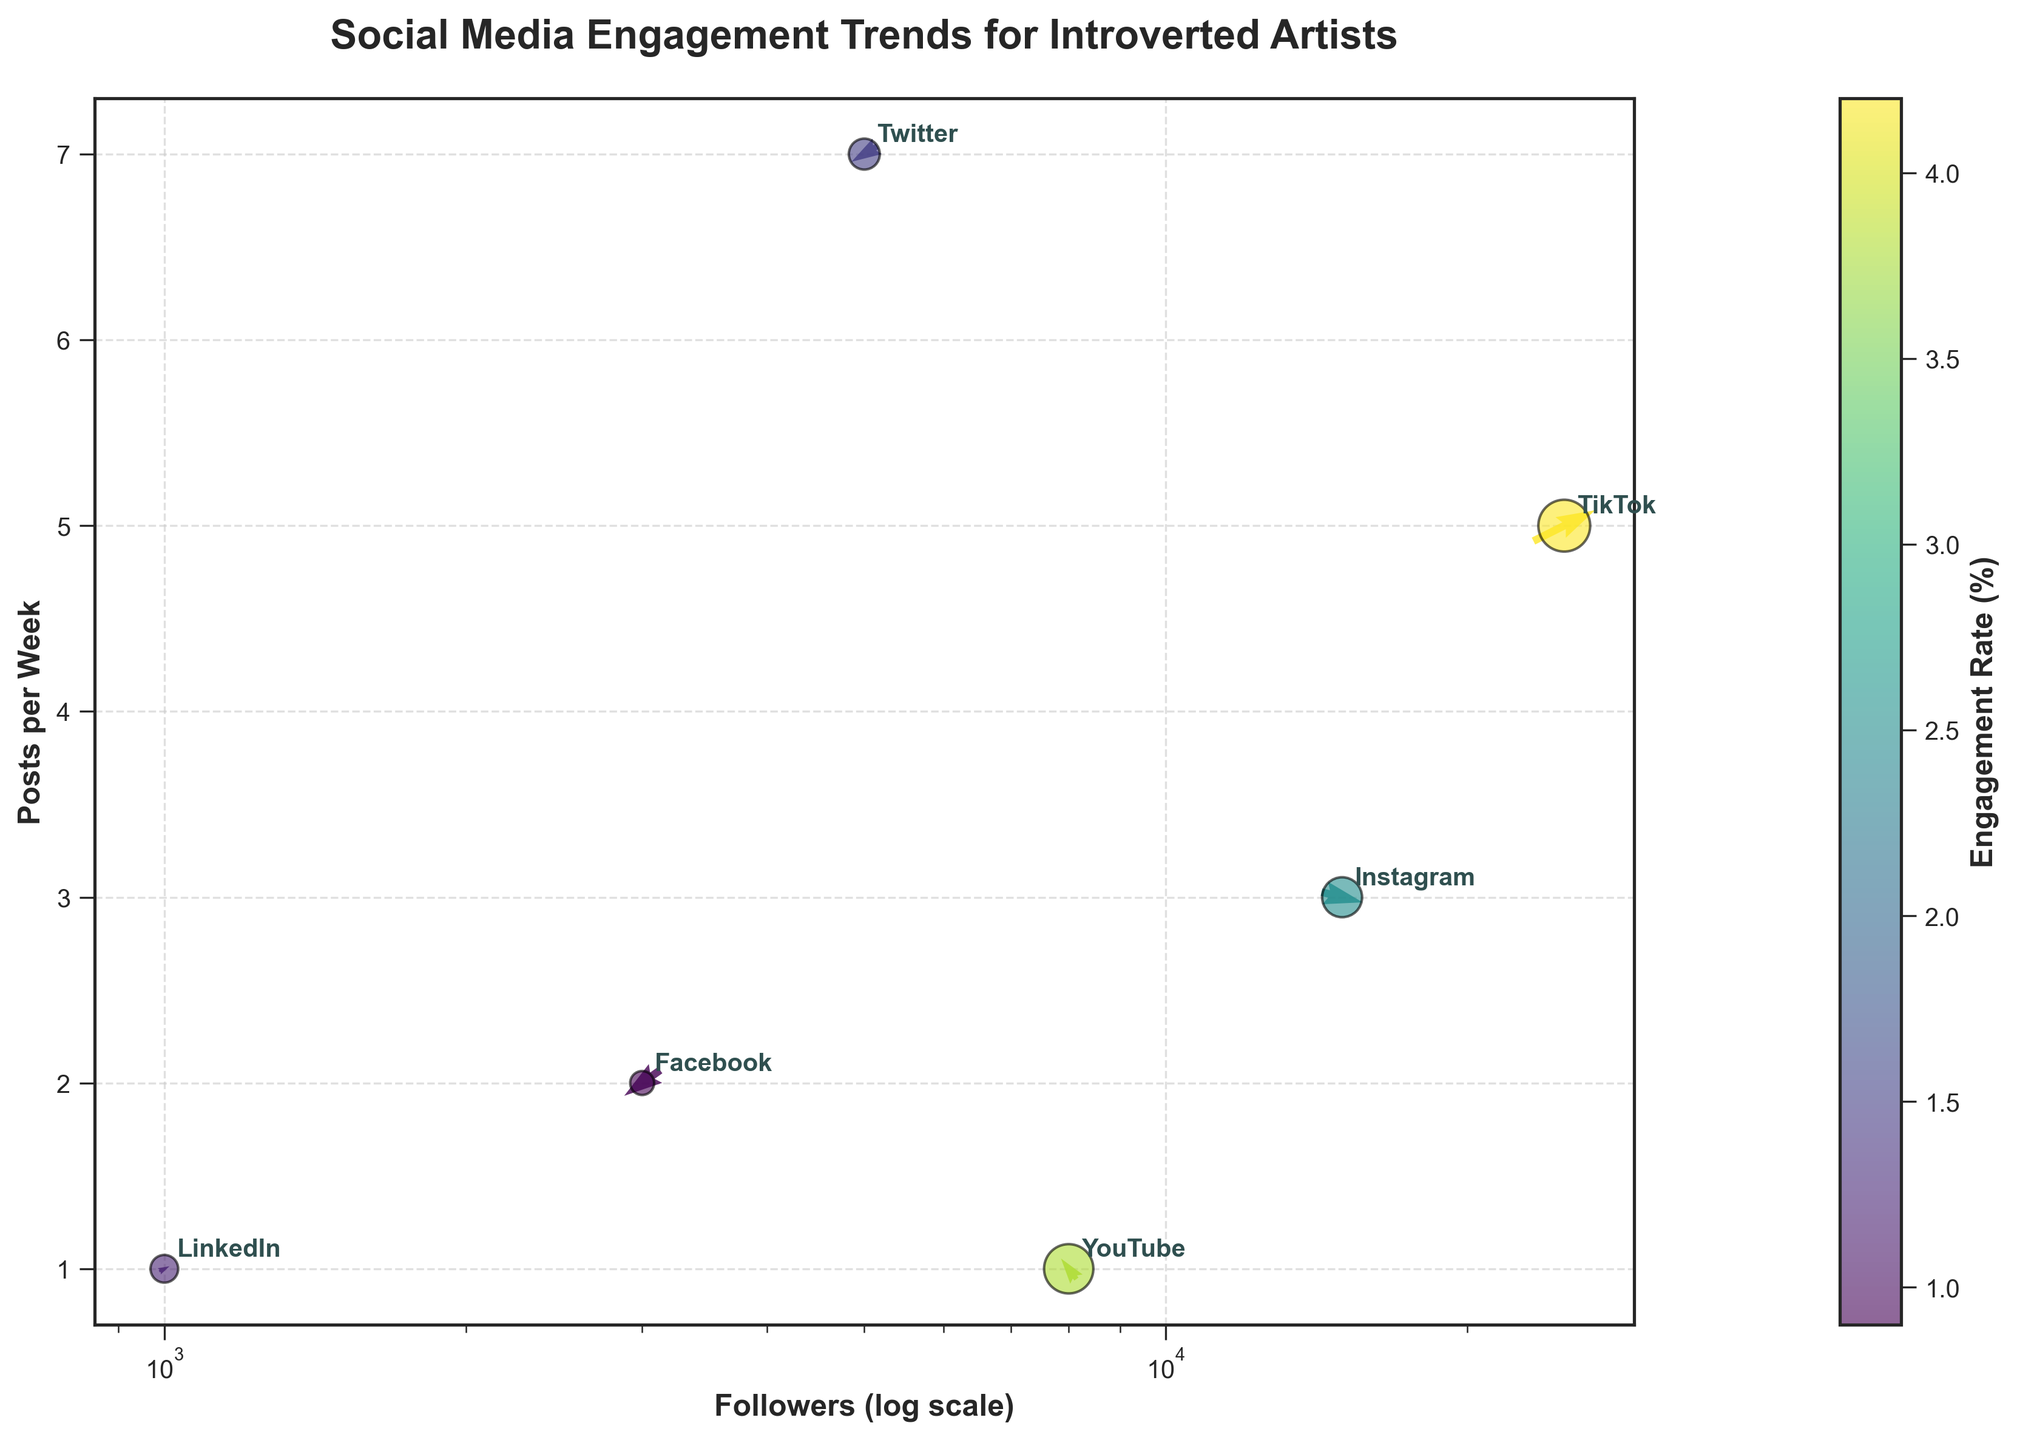How many platforms are shown in the plot? There are six platforms annotated in the plot: Instagram, TikTok, YouTube, Twitter, Facebook, and LinkedIn.
Answer: Six Which platform has the highest engagement rate? TikTok has the highest engagement rate, indicated by the largest size of the circle and the highest value in the color bar.
Answer: TikTok What is the trend direction for Facebook? The trend direction for Facebook has arrows pointing left and downward, indicating negative values in both x and y directions.
Answer: Left and downward Compare the engagement rates of Instagram and Twitter. Which one is higher? By looking at the size and color of the circles, it shows that Instagram has a higher engagement rate compared to Twitter.
Answer: Instagram What information is represented by the length and direction of the arrows? The length and direction of the arrows represent the trend direction (x and y components) for each social media platform.
Answer: Trend direction What is the difference in posts per week between YouTube and Facebook? YouTube has 1 post per week, and Facebook has 2 posts per week. The difference is calculated as 2 - 1 = 1 post per week.
Answer: 1 post per week Which platform has the most followers and how can you tell? TikTok has the most followers as indicated by its position on the x-axis being the furthest right.
Answer: TikTok What does the color of the arrows indicate? The color of the arrows indicates the engagement rate percentage, with the color bar showing the scale from lower to higher engagement rates.
Answer: Engagement rate Is there a positive or negative trend in engagement for LinkedIn? The arrow for LinkedIn points slightly upwards and to the right, indicating a positive trend.
Answer: Positive Among the platforms, which one has the least number of followers? LinkedIn has the least number of followers as shown by its leftmost position on the x-axis.
Answer: LinkedIn 